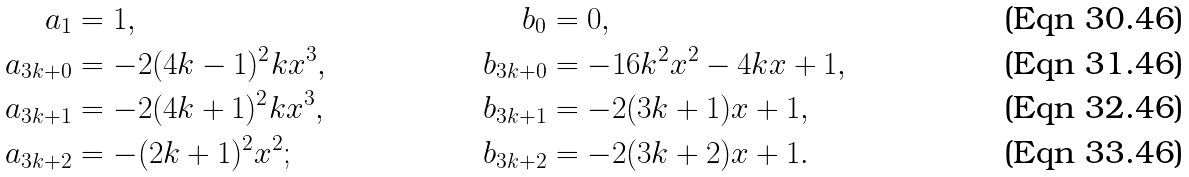<formula> <loc_0><loc_0><loc_500><loc_500>a _ { 1 } & = 1 , & b _ { 0 } & = 0 , \\ a _ { 3 k + 0 } & = - 2 ( 4 k - 1 ) ^ { 2 } k x ^ { 3 } , & b _ { 3 k + 0 } & = - 1 6 k ^ { 2 } x ^ { 2 } - 4 k x + 1 , \\ a _ { 3 k + 1 } & = - 2 ( 4 k + 1 ) ^ { 2 } k x ^ { 3 } , & b _ { 3 k + 1 } & = - 2 ( 3 k + 1 ) x + 1 , \\ a _ { 3 k + 2 } & = - ( 2 k + 1 ) ^ { 2 } x ^ { 2 } ; & b _ { 3 k + 2 } & = - 2 ( 3 k + 2 ) x + 1 .</formula> 